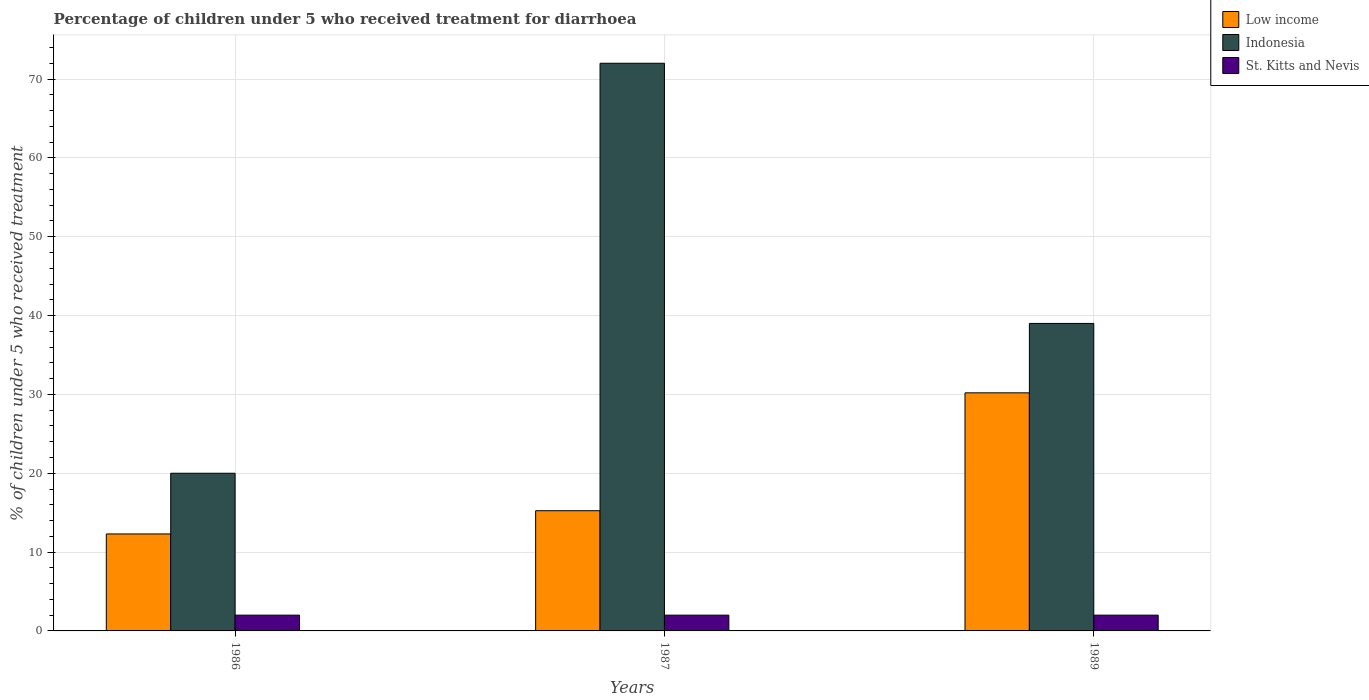How many groups of bars are there?
Your answer should be very brief. 3. Are the number of bars on each tick of the X-axis equal?
Ensure brevity in your answer.  Yes. What is the label of the 3rd group of bars from the left?
Keep it short and to the point. 1989. What is the percentage of children who received treatment for diarrhoea  in St. Kitts and Nevis in 1989?
Keep it short and to the point. 2. Across all years, what is the maximum percentage of children who received treatment for diarrhoea  in Low income?
Offer a very short reply. 30.2. Across all years, what is the minimum percentage of children who received treatment for diarrhoea  in St. Kitts and Nevis?
Your answer should be very brief. 2. In which year was the percentage of children who received treatment for diarrhoea  in St. Kitts and Nevis maximum?
Offer a very short reply. 1986. In which year was the percentage of children who received treatment for diarrhoea  in Indonesia minimum?
Provide a short and direct response. 1986. What is the difference between the percentage of children who received treatment for diarrhoea  in Low income in 1986 and that in 1989?
Your answer should be very brief. -17.9. What is the difference between the percentage of children who received treatment for diarrhoea  in Low income in 1986 and the percentage of children who received treatment for diarrhoea  in St. Kitts and Nevis in 1987?
Provide a short and direct response. 10.3. What is the average percentage of children who received treatment for diarrhoea  in Indonesia per year?
Keep it short and to the point. 43.67. What is the ratio of the percentage of children who received treatment for diarrhoea  in Indonesia in 1986 to that in 1987?
Your response must be concise. 0.28. What is the difference between the highest and the second highest percentage of children who received treatment for diarrhoea  in Low income?
Offer a terse response. 14.95. What does the 3rd bar from the left in 1987 represents?
Your answer should be compact. St. Kitts and Nevis. What does the 2nd bar from the right in 1989 represents?
Your response must be concise. Indonesia. Is it the case that in every year, the sum of the percentage of children who received treatment for diarrhoea  in Low income and percentage of children who received treatment for diarrhoea  in St. Kitts and Nevis is greater than the percentage of children who received treatment for diarrhoea  in Indonesia?
Offer a very short reply. No. Are all the bars in the graph horizontal?
Your response must be concise. No. Are the values on the major ticks of Y-axis written in scientific E-notation?
Keep it short and to the point. No. Where does the legend appear in the graph?
Offer a terse response. Top right. How many legend labels are there?
Ensure brevity in your answer.  3. What is the title of the graph?
Ensure brevity in your answer.  Percentage of children under 5 who received treatment for diarrhoea. What is the label or title of the X-axis?
Provide a short and direct response. Years. What is the label or title of the Y-axis?
Your answer should be very brief. % of children under 5 who received treatment. What is the % of children under 5 who received treatment in Low income in 1986?
Give a very brief answer. 12.3. What is the % of children under 5 who received treatment of Low income in 1987?
Provide a short and direct response. 15.25. What is the % of children under 5 who received treatment of Indonesia in 1987?
Ensure brevity in your answer.  72. What is the % of children under 5 who received treatment in Low income in 1989?
Offer a very short reply. 30.2. What is the % of children under 5 who received treatment of Indonesia in 1989?
Your answer should be very brief. 39. Across all years, what is the maximum % of children under 5 who received treatment of Low income?
Your response must be concise. 30.2. Across all years, what is the minimum % of children under 5 who received treatment of Low income?
Make the answer very short. 12.3. Across all years, what is the minimum % of children under 5 who received treatment of Indonesia?
Give a very brief answer. 20. Across all years, what is the minimum % of children under 5 who received treatment in St. Kitts and Nevis?
Your response must be concise. 2. What is the total % of children under 5 who received treatment of Low income in the graph?
Your response must be concise. 57.74. What is the total % of children under 5 who received treatment of Indonesia in the graph?
Your answer should be compact. 131. What is the difference between the % of children under 5 who received treatment in Low income in 1986 and that in 1987?
Offer a terse response. -2.95. What is the difference between the % of children under 5 who received treatment of Indonesia in 1986 and that in 1987?
Give a very brief answer. -52. What is the difference between the % of children under 5 who received treatment of St. Kitts and Nevis in 1986 and that in 1987?
Your answer should be very brief. 0. What is the difference between the % of children under 5 who received treatment of Low income in 1986 and that in 1989?
Provide a succinct answer. -17.9. What is the difference between the % of children under 5 who received treatment in St. Kitts and Nevis in 1986 and that in 1989?
Provide a short and direct response. 0. What is the difference between the % of children under 5 who received treatment in Low income in 1987 and that in 1989?
Provide a succinct answer. -14.95. What is the difference between the % of children under 5 who received treatment of Indonesia in 1987 and that in 1989?
Provide a succinct answer. 33. What is the difference between the % of children under 5 who received treatment of St. Kitts and Nevis in 1987 and that in 1989?
Ensure brevity in your answer.  0. What is the difference between the % of children under 5 who received treatment in Low income in 1986 and the % of children under 5 who received treatment in Indonesia in 1987?
Your response must be concise. -59.7. What is the difference between the % of children under 5 who received treatment of Low income in 1986 and the % of children under 5 who received treatment of St. Kitts and Nevis in 1987?
Your answer should be very brief. 10.3. What is the difference between the % of children under 5 who received treatment in Low income in 1986 and the % of children under 5 who received treatment in Indonesia in 1989?
Ensure brevity in your answer.  -26.7. What is the difference between the % of children under 5 who received treatment of Low income in 1986 and the % of children under 5 who received treatment of St. Kitts and Nevis in 1989?
Make the answer very short. 10.3. What is the difference between the % of children under 5 who received treatment in Low income in 1987 and the % of children under 5 who received treatment in Indonesia in 1989?
Your answer should be very brief. -23.75. What is the difference between the % of children under 5 who received treatment in Low income in 1987 and the % of children under 5 who received treatment in St. Kitts and Nevis in 1989?
Ensure brevity in your answer.  13.25. What is the average % of children under 5 who received treatment in Low income per year?
Provide a succinct answer. 19.25. What is the average % of children under 5 who received treatment in Indonesia per year?
Your answer should be very brief. 43.67. What is the average % of children under 5 who received treatment of St. Kitts and Nevis per year?
Make the answer very short. 2. In the year 1986, what is the difference between the % of children under 5 who received treatment in Low income and % of children under 5 who received treatment in Indonesia?
Provide a short and direct response. -7.7. In the year 1986, what is the difference between the % of children under 5 who received treatment in Low income and % of children under 5 who received treatment in St. Kitts and Nevis?
Ensure brevity in your answer.  10.3. In the year 1986, what is the difference between the % of children under 5 who received treatment of Indonesia and % of children under 5 who received treatment of St. Kitts and Nevis?
Offer a very short reply. 18. In the year 1987, what is the difference between the % of children under 5 who received treatment in Low income and % of children under 5 who received treatment in Indonesia?
Give a very brief answer. -56.75. In the year 1987, what is the difference between the % of children under 5 who received treatment in Low income and % of children under 5 who received treatment in St. Kitts and Nevis?
Make the answer very short. 13.25. In the year 1987, what is the difference between the % of children under 5 who received treatment in Indonesia and % of children under 5 who received treatment in St. Kitts and Nevis?
Keep it short and to the point. 70. In the year 1989, what is the difference between the % of children under 5 who received treatment of Low income and % of children under 5 who received treatment of Indonesia?
Offer a terse response. -8.8. In the year 1989, what is the difference between the % of children under 5 who received treatment in Low income and % of children under 5 who received treatment in St. Kitts and Nevis?
Offer a very short reply. 28.2. In the year 1989, what is the difference between the % of children under 5 who received treatment in Indonesia and % of children under 5 who received treatment in St. Kitts and Nevis?
Ensure brevity in your answer.  37. What is the ratio of the % of children under 5 who received treatment of Low income in 1986 to that in 1987?
Ensure brevity in your answer.  0.81. What is the ratio of the % of children under 5 who received treatment of Indonesia in 1986 to that in 1987?
Offer a terse response. 0.28. What is the ratio of the % of children under 5 who received treatment of Low income in 1986 to that in 1989?
Make the answer very short. 0.41. What is the ratio of the % of children under 5 who received treatment of Indonesia in 1986 to that in 1989?
Offer a very short reply. 0.51. What is the ratio of the % of children under 5 who received treatment in Low income in 1987 to that in 1989?
Keep it short and to the point. 0.5. What is the ratio of the % of children under 5 who received treatment in Indonesia in 1987 to that in 1989?
Ensure brevity in your answer.  1.85. What is the ratio of the % of children under 5 who received treatment of St. Kitts and Nevis in 1987 to that in 1989?
Make the answer very short. 1. What is the difference between the highest and the second highest % of children under 5 who received treatment in Low income?
Provide a short and direct response. 14.95. What is the difference between the highest and the lowest % of children under 5 who received treatment of Low income?
Offer a very short reply. 17.9. What is the difference between the highest and the lowest % of children under 5 who received treatment of Indonesia?
Offer a terse response. 52. 